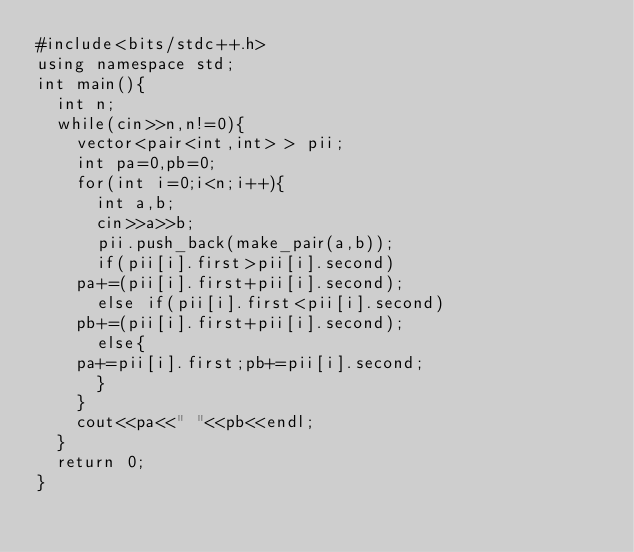<code> <loc_0><loc_0><loc_500><loc_500><_C++_>#include<bits/stdc++.h>
using namespace std;
int main(){
  int n;
  while(cin>>n,n!=0){
    vector<pair<int,int> > pii;
    int pa=0,pb=0;
    for(int i=0;i<n;i++){
      int a,b;
      cin>>a>>b;
      pii.push_back(make_pair(a,b));
      if(pii[i].first>pii[i].second)
	pa+=(pii[i].first+pii[i].second);
      else if(pii[i].first<pii[i].second)
	pb+=(pii[i].first+pii[i].second);
      else{
	pa+=pii[i].first;pb+=pii[i].second;
      }
    }
    cout<<pa<<" "<<pb<<endl;
  }
  return 0;
}</code> 